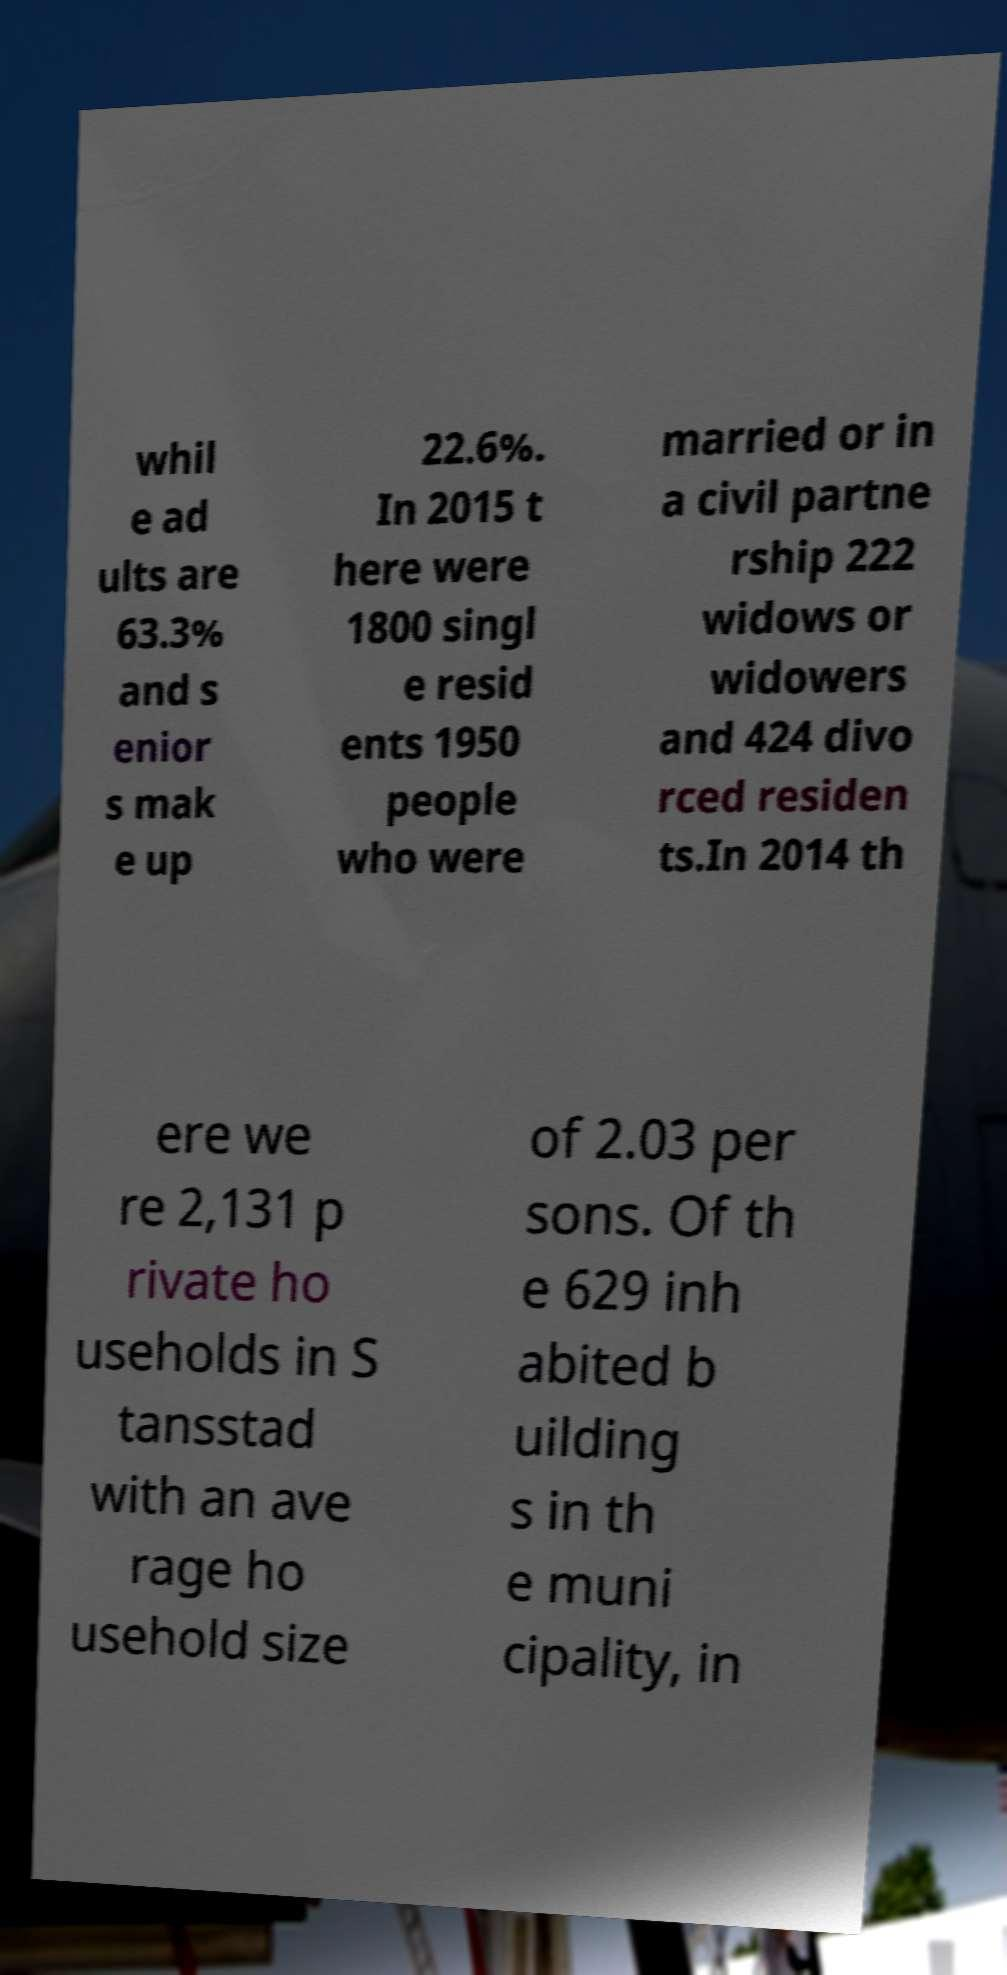I need the written content from this picture converted into text. Can you do that? whil e ad ults are 63.3% and s enior s mak e up 22.6%. In 2015 t here were 1800 singl e resid ents 1950 people who were married or in a civil partne rship 222 widows or widowers and 424 divo rced residen ts.In 2014 th ere we re 2,131 p rivate ho useholds in S tansstad with an ave rage ho usehold size of 2.03 per sons. Of th e 629 inh abited b uilding s in th e muni cipality, in 